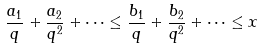Convert formula to latex. <formula><loc_0><loc_0><loc_500><loc_500>\frac { a _ { 1 } } { q } + \frac { a _ { 2 } } { q ^ { 2 } } + \cdots \leq \frac { b _ { 1 } } { q } + \frac { b _ { 2 } } { q ^ { 2 } } + \cdots \leq x</formula> 